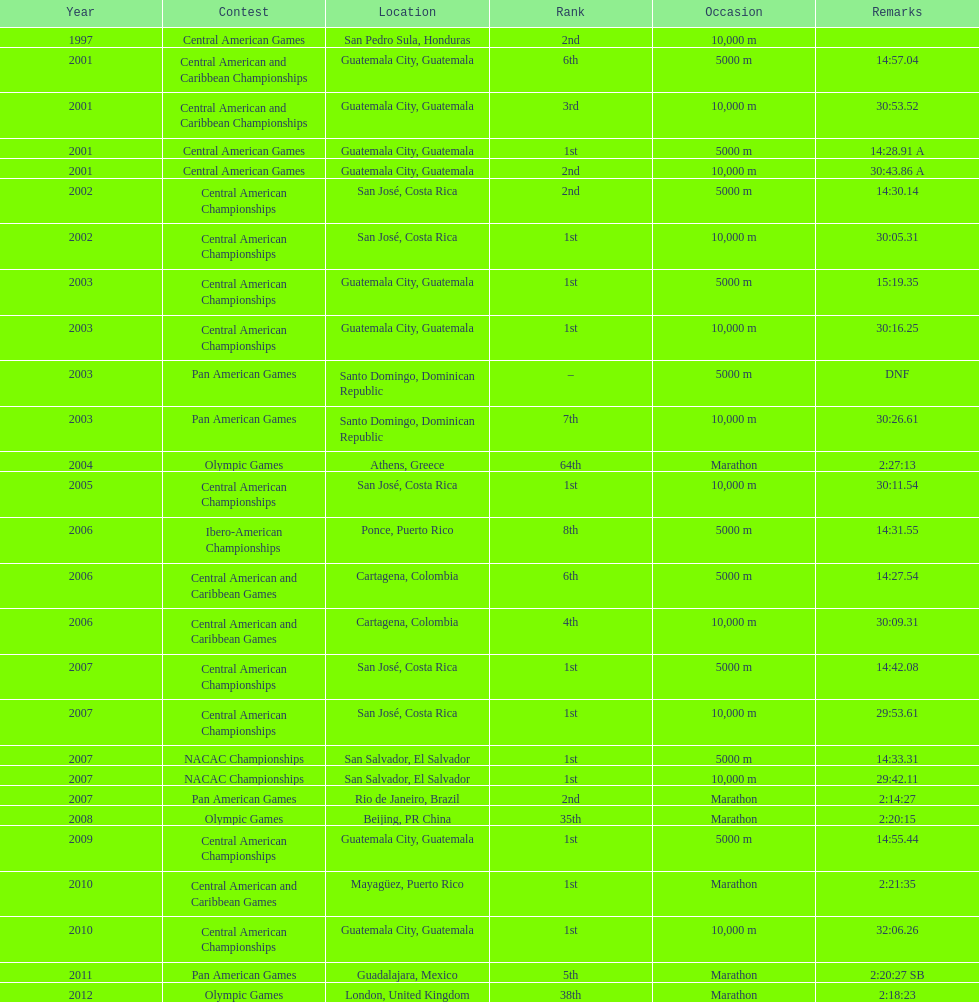Tell me the number of times they competed in guatamala. 5. 